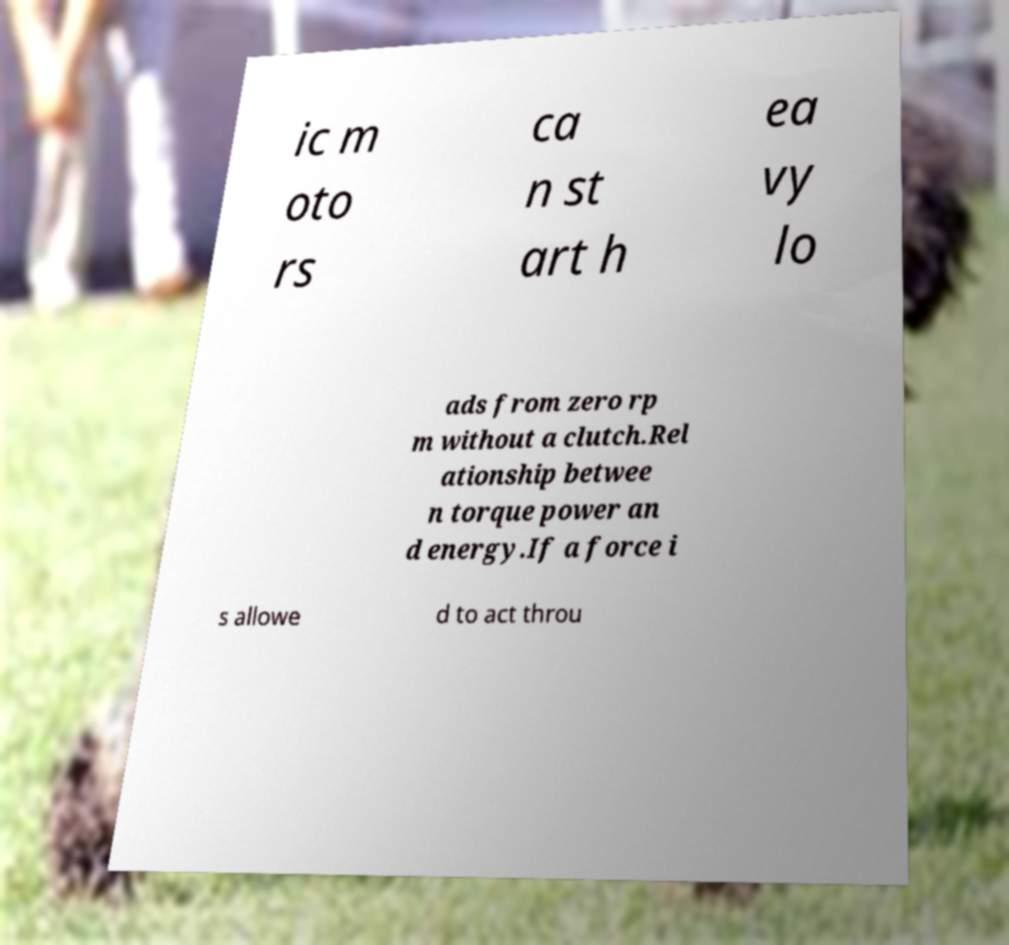For documentation purposes, I need the text within this image transcribed. Could you provide that? ic m oto rs ca n st art h ea vy lo ads from zero rp m without a clutch.Rel ationship betwee n torque power an d energy.If a force i s allowe d to act throu 